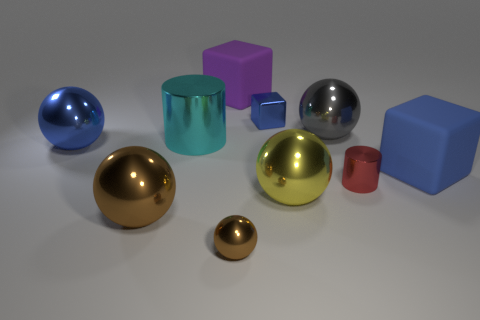How big is the gray shiny object?
Provide a short and direct response. Large. How many other things are the same size as the red object?
Offer a very short reply. 2. Do the tiny metallic cube and the small metallic ball have the same color?
Your response must be concise. No. Are the blue cube behind the blue metal sphere and the big block behind the cyan thing made of the same material?
Your answer should be very brief. No. Is the number of blue metallic spheres greater than the number of metallic spheres?
Keep it short and to the point. No. Is there anything else that has the same color as the tiny shiny cylinder?
Offer a very short reply. No. Is the yellow sphere made of the same material as the purple cube?
Provide a succinct answer. No. Is the number of small brown blocks less than the number of blue matte objects?
Keep it short and to the point. Yes. Is the shape of the red thing the same as the purple matte object?
Your answer should be compact. No. What is the color of the small metal sphere?
Provide a succinct answer. Brown. 